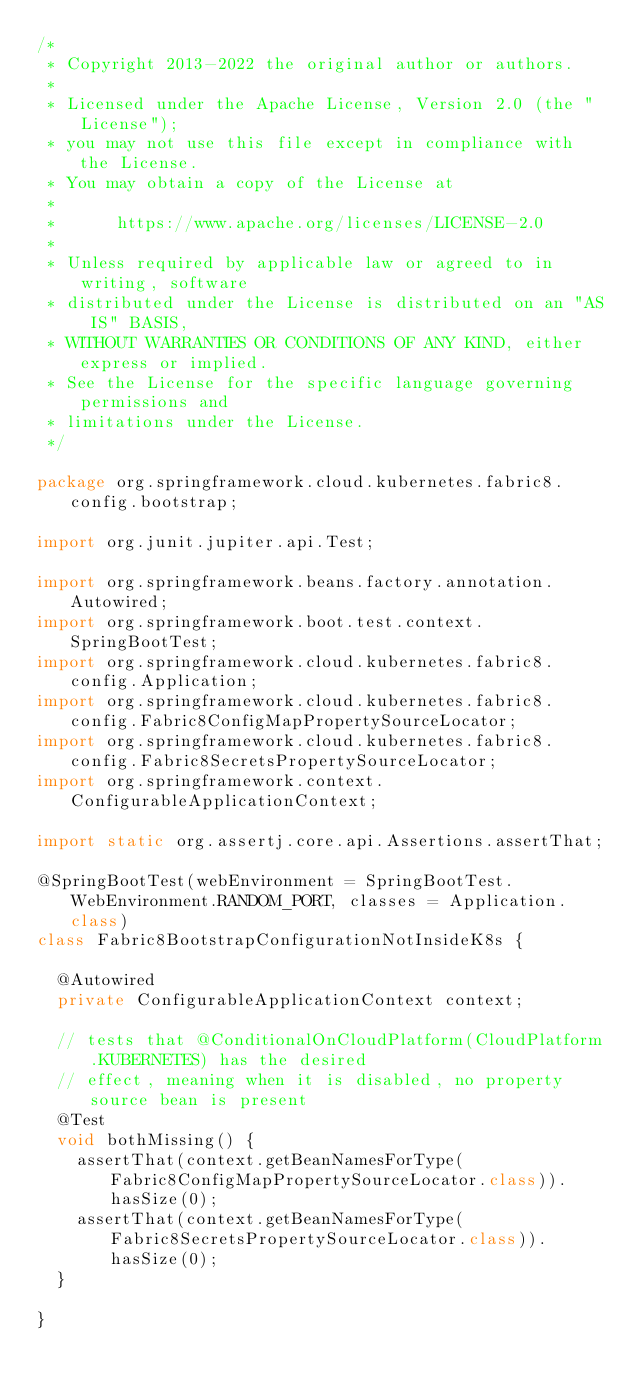<code> <loc_0><loc_0><loc_500><loc_500><_Java_>/*
 * Copyright 2013-2022 the original author or authors.
 *
 * Licensed under the Apache License, Version 2.0 (the "License");
 * you may not use this file except in compliance with the License.
 * You may obtain a copy of the License at
 *
 *      https://www.apache.org/licenses/LICENSE-2.0
 *
 * Unless required by applicable law or agreed to in writing, software
 * distributed under the License is distributed on an "AS IS" BASIS,
 * WITHOUT WARRANTIES OR CONDITIONS OF ANY KIND, either express or implied.
 * See the License for the specific language governing permissions and
 * limitations under the License.
 */

package org.springframework.cloud.kubernetes.fabric8.config.bootstrap;

import org.junit.jupiter.api.Test;

import org.springframework.beans.factory.annotation.Autowired;
import org.springframework.boot.test.context.SpringBootTest;
import org.springframework.cloud.kubernetes.fabric8.config.Application;
import org.springframework.cloud.kubernetes.fabric8.config.Fabric8ConfigMapPropertySourceLocator;
import org.springframework.cloud.kubernetes.fabric8.config.Fabric8SecretsPropertySourceLocator;
import org.springframework.context.ConfigurableApplicationContext;

import static org.assertj.core.api.Assertions.assertThat;

@SpringBootTest(webEnvironment = SpringBootTest.WebEnvironment.RANDOM_PORT, classes = Application.class)
class Fabric8BootstrapConfigurationNotInsideK8s {

	@Autowired
	private ConfigurableApplicationContext context;

	// tests that @ConditionalOnCloudPlatform(CloudPlatform.KUBERNETES) has the desired
	// effect, meaning when it is disabled, no property source bean is present
	@Test
	void bothMissing() {
		assertThat(context.getBeanNamesForType(Fabric8ConfigMapPropertySourceLocator.class)).hasSize(0);
		assertThat(context.getBeanNamesForType(Fabric8SecretsPropertySourceLocator.class)).hasSize(0);
	}

}
</code> 